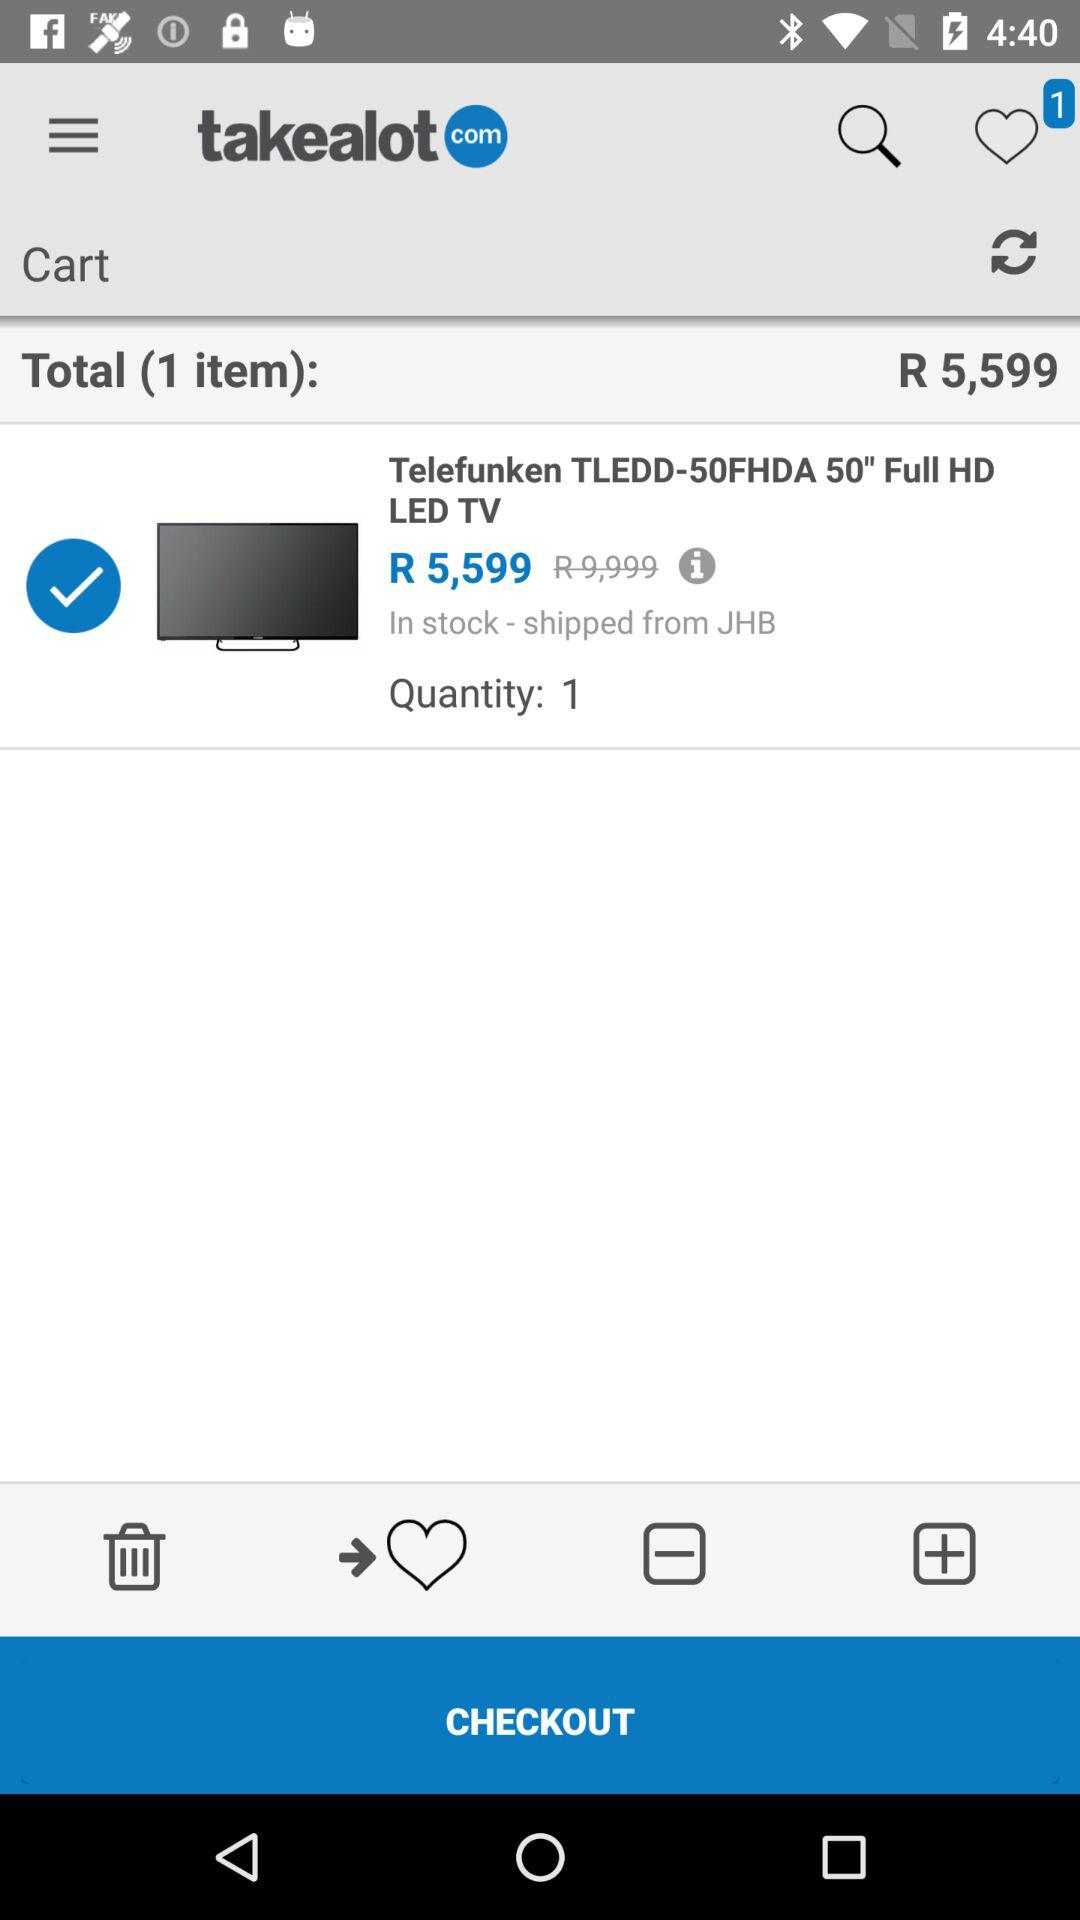What is the quantity of the item in the cart? The quantity is 1. 